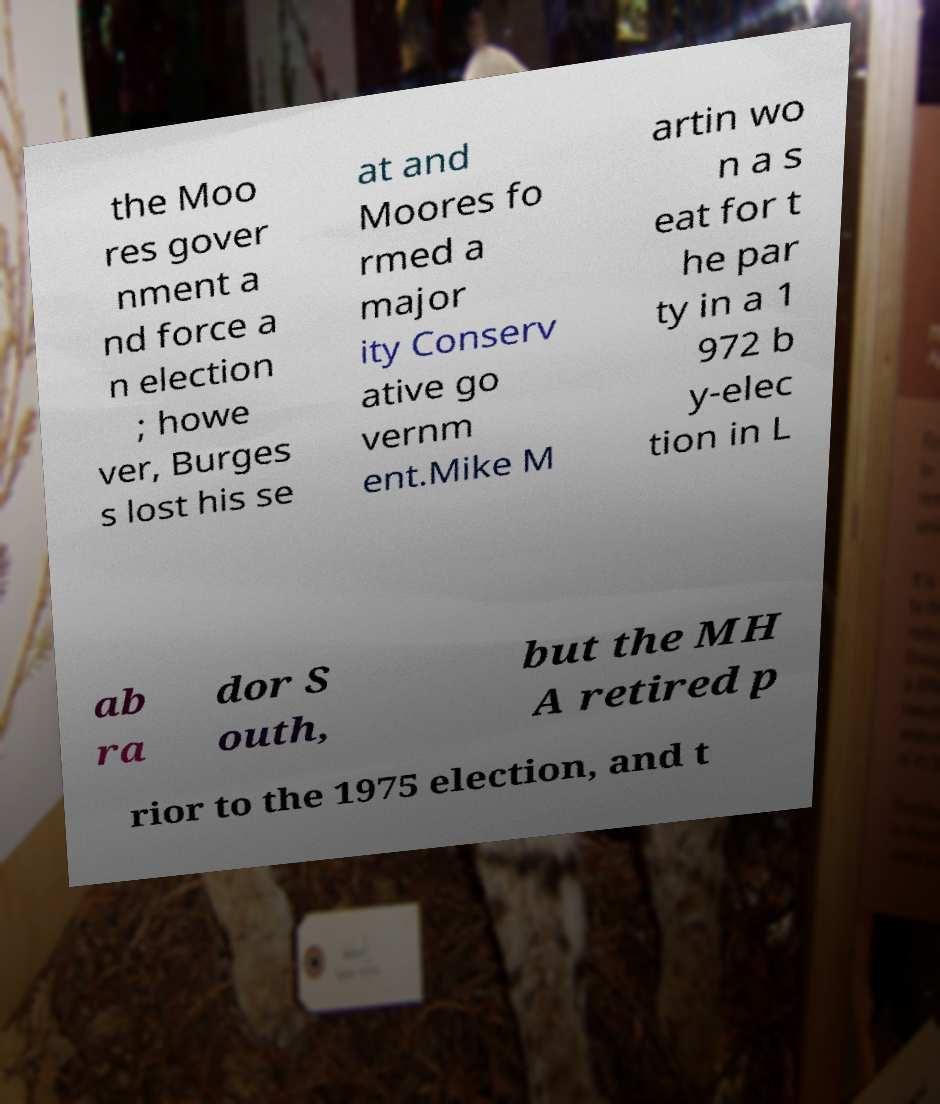I need the written content from this picture converted into text. Can you do that? the Moo res gover nment a nd force a n election ; howe ver, Burges s lost his se at and Moores fo rmed a major ity Conserv ative go vernm ent.Mike M artin wo n a s eat for t he par ty in a 1 972 b y-elec tion in L ab ra dor S outh, but the MH A retired p rior to the 1975 election, and t 